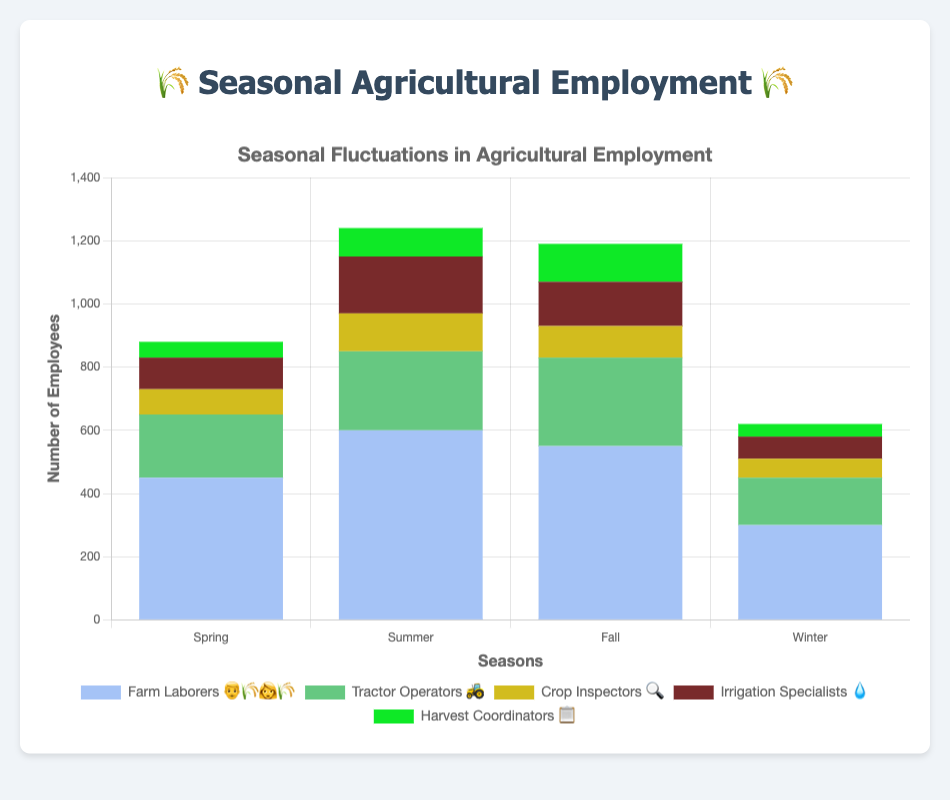Which season has the highest number of Farm Laborers 👨‍🌾👩‍🌾 employed? Farm Laborers employment is given for each season. The highest number is in Summer with 600.
Answer: Summer Which job type 🚜 has the second-lowest employment in Winter? Among the given job types, Tractor Operators (150) has higher employment than Crop Inspectors (60) and Harvest Coordinators (40), but less than Farm Laborers (300) and Irrigation Specialists (70).
Answer: Irrigation Specialists 💧 What is the total number of employees in Fall? Sum the employment across all job types for Fall: 550 (Farm Laborers) + 280 (Tractor Operators) + 100 (Crop Inspectors) + 140 (Irrigation Specialists) + 120 (Harvest Coordinators) = 1190.
Answer: 1190 By how much does the employment of Tractor Operators 🚜 increase from Spring to Fall? The employment in Spring is 200 and in Fall is 280. The difference is 280 - 200 = 80.
Answer: 80 Which season has the least number of Harvest Coordinators 📋 employed? The employment numbers for Harvest Coordinators are 50 (Spring), 90 (Summer), 120 (Fall), and 40 (Winter). The smallest number is in Winter with 40.
Answer: Winter How many more Farm Laborers 👨‍🌾👩‍🌾 are employed in Summer compared to Winter? Farm Laborers employment in Summer is 600 and in Winter is 300. The difference is 600 - 300 = 300.
Answer: 300 What is the average number of employees for Irrigation Specialists 💧 over all seasons? Sum the employment numbers for Irrigation Specialists: 100 (Spring) + 180 (Summer) + 140 (Fall) + 70 (Winter) = 490. The average is 490 / 4 = 122.5.
Answer: 122.5 Which job type 🔍 has the most significant seasonal fluctuation in employment? Compare the range of fluctuations (highest - lowest employment) for each job type:
- Farm Laborers: 600 - 300 = 300
- Tractor Operators: 280 - 150 = 130
- Crop Inspectors: 120 - 60 = 60
- Irrigation Specialists: 180 - 70 = 110
- Harvest Coordinators: 120 - 40 = 80
Farm Laborers have the most significant seasonal fluctuation with a range of 300.
Answer: Farm Laborers 👨‍🌾👩‍🌾 What is the combined employment of Crop Inspectors 🔍 and Harvest Coordinators 📋 in Summer? Sum the Summer employment for Crop Inspectors and Harvest Coordinators: 120 + 90 = 210.
Answer: 210 